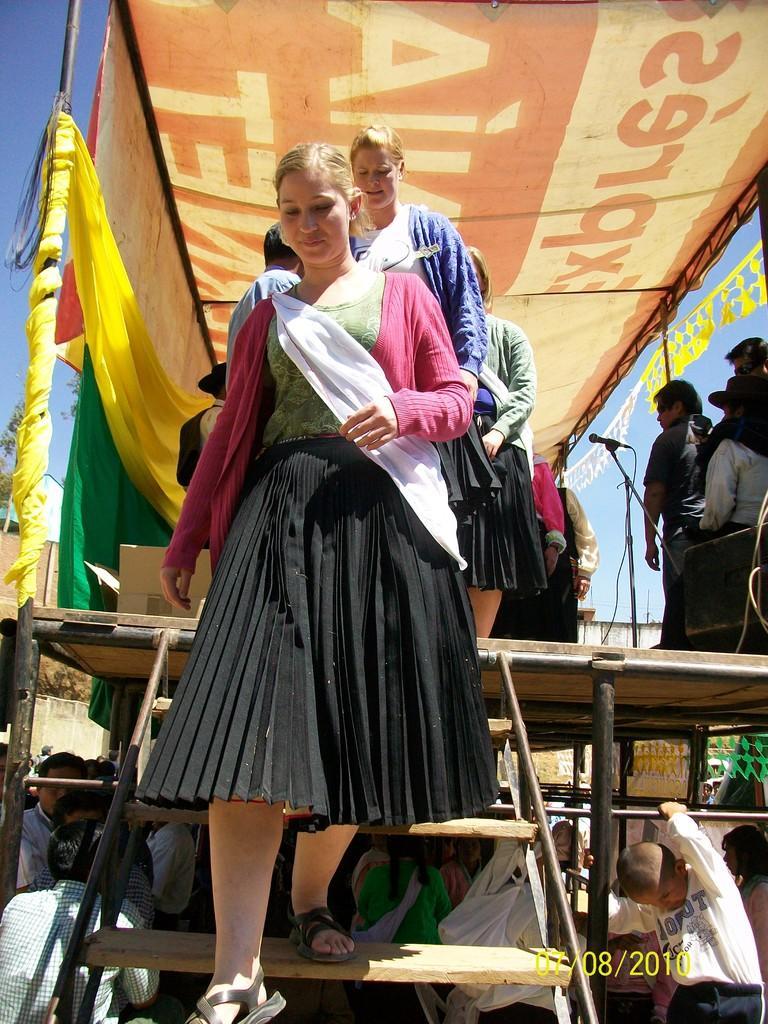How would you summarize this image in a sentence or two? In this image there are group of persons. In the front there is a woman getting down on the steps with a smile on her face and on the top there is a banner. On the left side there are curtains which are yellow and green in colour. 